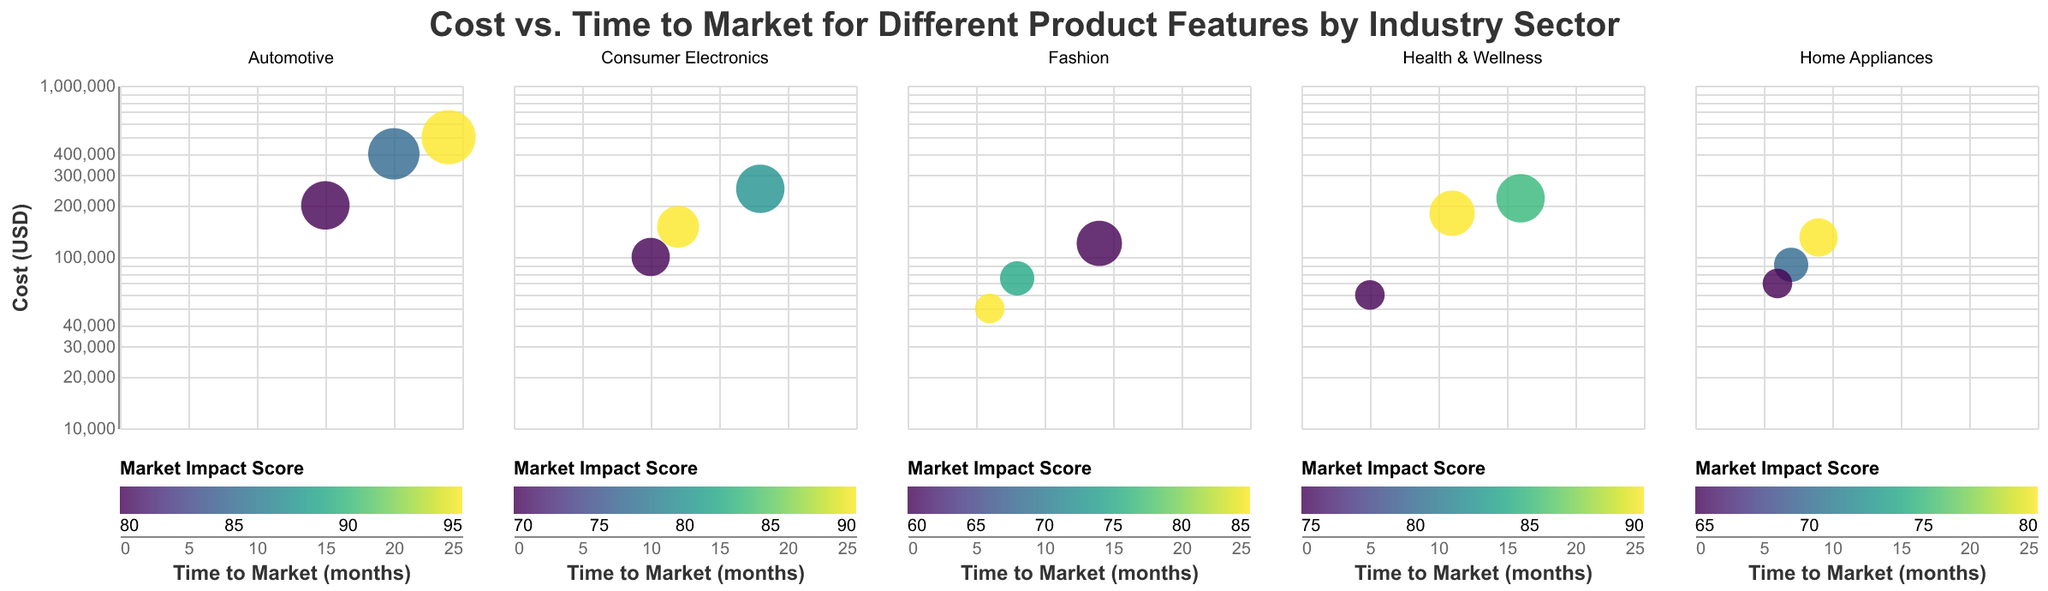What's the title of the plot? The title of the plot is typically found at the center top of the chart and provides an overview of the data represented.
Answer: Cost vs. Time to Market for Different Product Features by Industry Sector Which product feature in the Automotive sector has the highest market impact score? To find the product feature with the highest market impact score in the Automotive sector, look for the bubble with the darkest color in that subplot.
Answer: Autonomous Driving What is the cost and time to market for Smart Textiles in the Fashion sector? Locate the bubble corresponding to Smart Textiles in the Fashion sector, then check its position on the x-axis and y-axis for time to market and cost, respectively.
Answer: Cost: 120,000 USD, Time to Market: 14 months Compare the cost of Wireless Charging in Consumer Electronics to Smart Wearables in Health & Wellness. Which one is more expensive? Locate the bubbles for Wireless Charging in Consumer Electronics and Smart Wearables in Health & Wellness and compare their y-axis positions where higher values indicate higher costs.
Answer: Wireless Charging How do Smart Wearables and Telehealth Integration compare in terms of their time to market in Health & Wellness? Find the positions of the bubbles for Smart Wearables and Telehealth Integration on the x-axis in the Health & Wellness subplot, then compare their values directly.
Answer: Smart Wearables: 11 months, Telehealth Integration: 16 months 